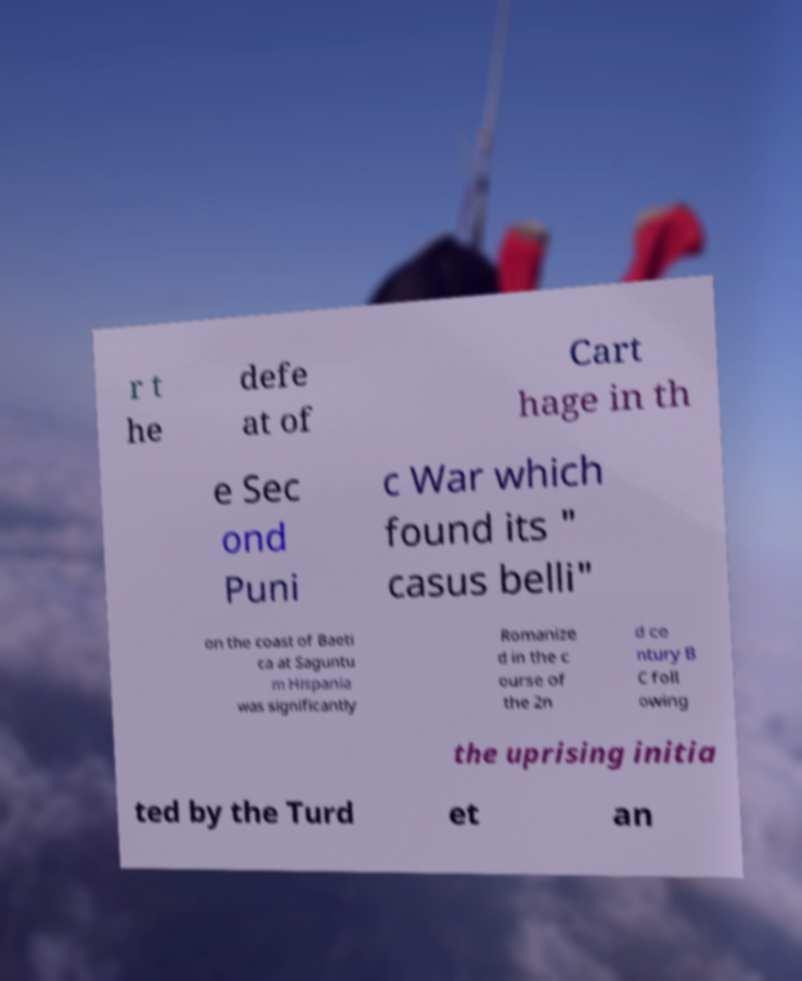Could you extract and type out the text from this image? r t he defe at of Cart hage in th e Sec ond Puni c War which found its " casus belli" on the coast of Baeti ca at Saguntu m Hispania was significantly Romanize d in the c ourse of the 2n d ce ntury B C foll owing the uprising initia ted by the Turd et an 